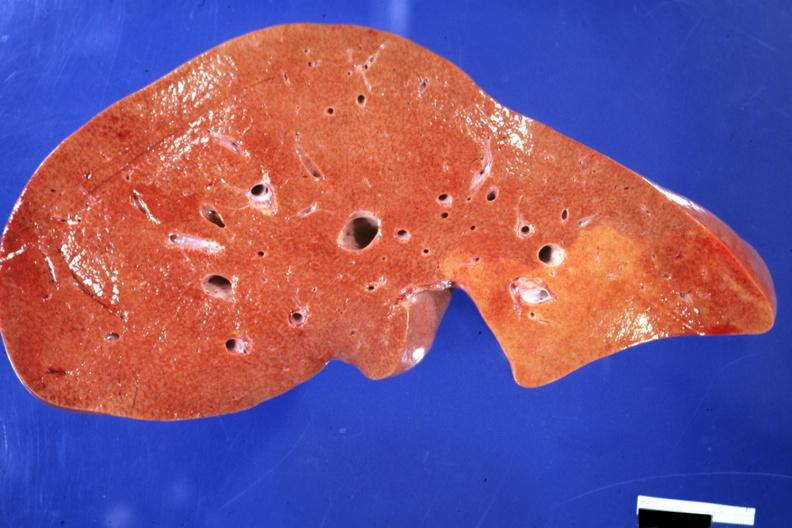does von show frontal section typical enlarged fatty liver with focal nutmeg areas?
Answer the question using a single word or phrase. No 